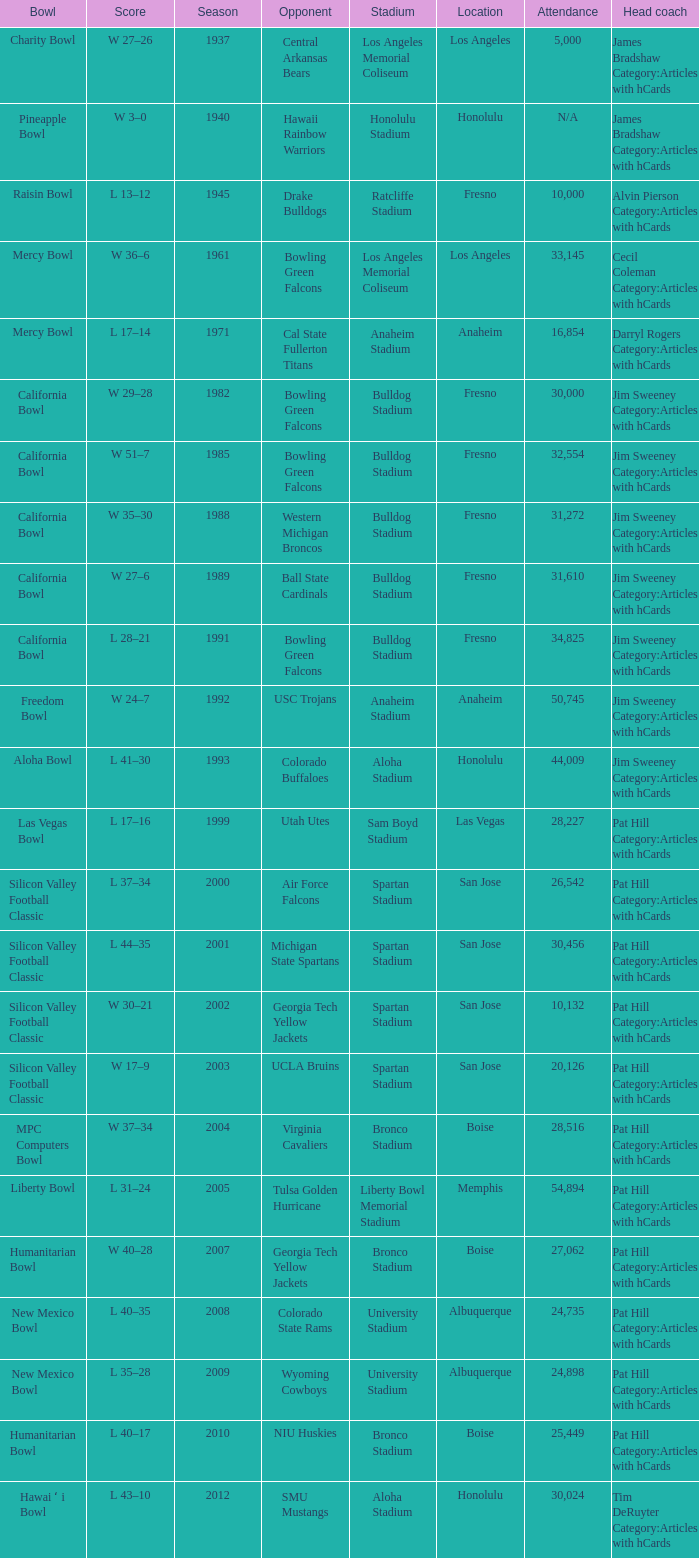What venue hosted an opponent of cal state fullerton titans? Anaheim Stadium. 